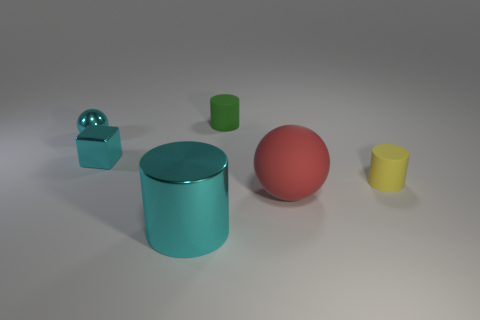Subtract all cyan metallic cylinders. How many cylinders are left? 2 Subtract all blocks. How many objects are left? 5 Add 2 big cyan objects. How many objects exist? 8 Subtract all cyan spheres. How many spheres are left? 1 Subtract 1 cylinders. How many cylinders are left? 2 Subtract 0 yellow spheres. How many objects are left? 6 Subtract all red cylinders. Subtract all yellow spheres. How many cylinders are left? 3 Subtract all tiny brown rubber blocks. Subtract all cyan metallic spheres. How many objects are left? 5 Add 1 metallic objects. How many metallic objects are left? 4 Add 4 small gray shiny balls. How many small gray shiny balls exist? 4 